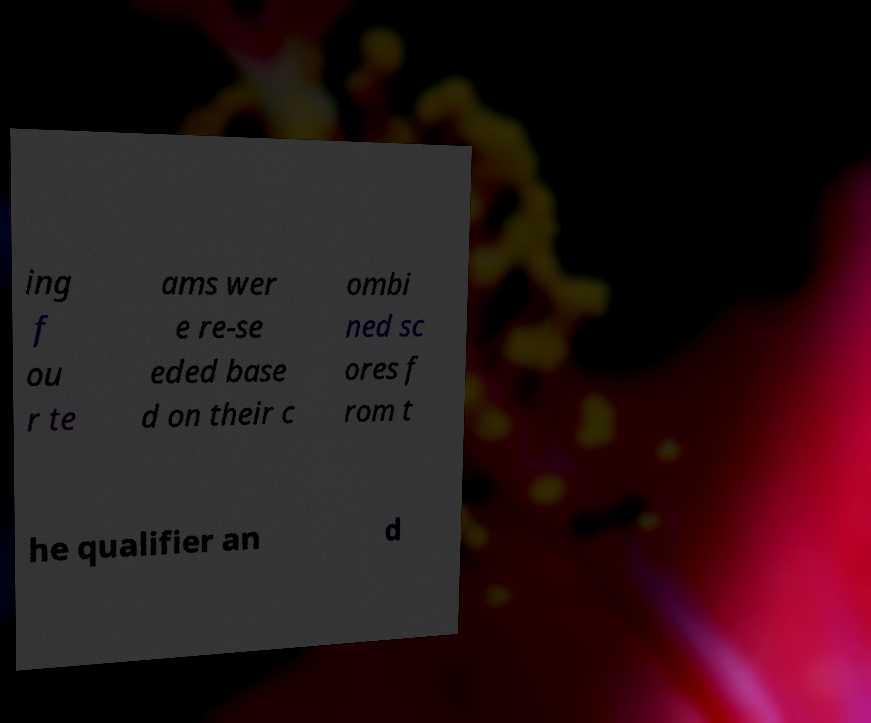What messages or text are displayed in this image? I need them in a readable, typed format. ing f ou r te ams wer e re-se eded base d on their c ombi ned sc ores f rom t he qualifier an d 